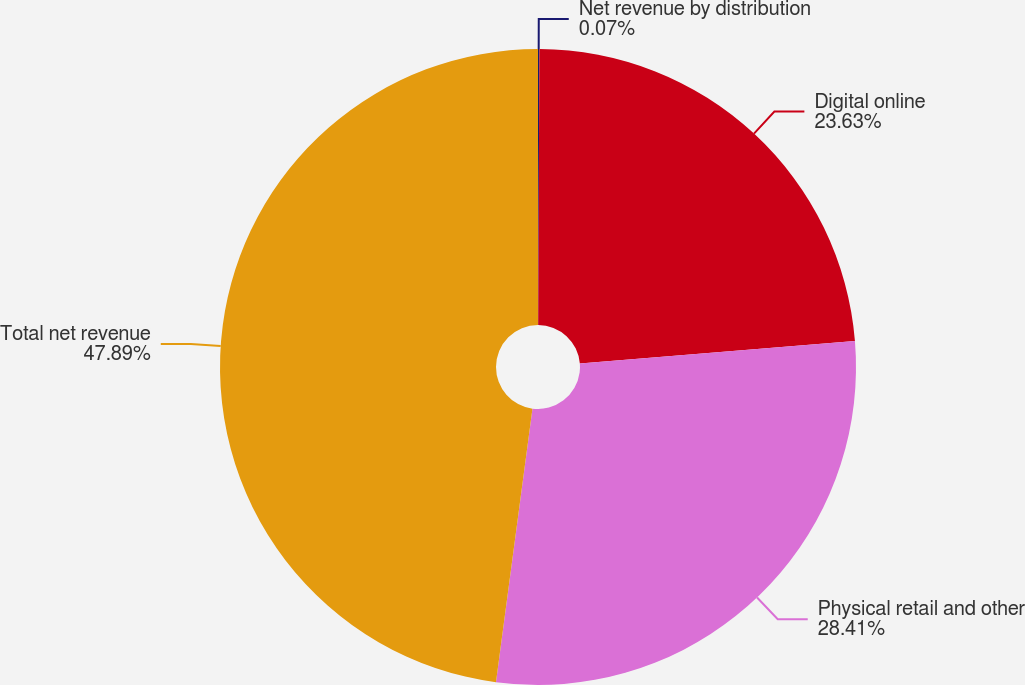<chart> <loc_0><loc_0><loc_500><loc_500><pie_chart><fcel>Net revenue by distribution<fcel>Digital online<fcel>Physical retail and other<fcel>Total net revenue<nl><fcel>0.07%<fcel>23.63%<fcel>28.41%<fcel>47.89%<nl></chart> 